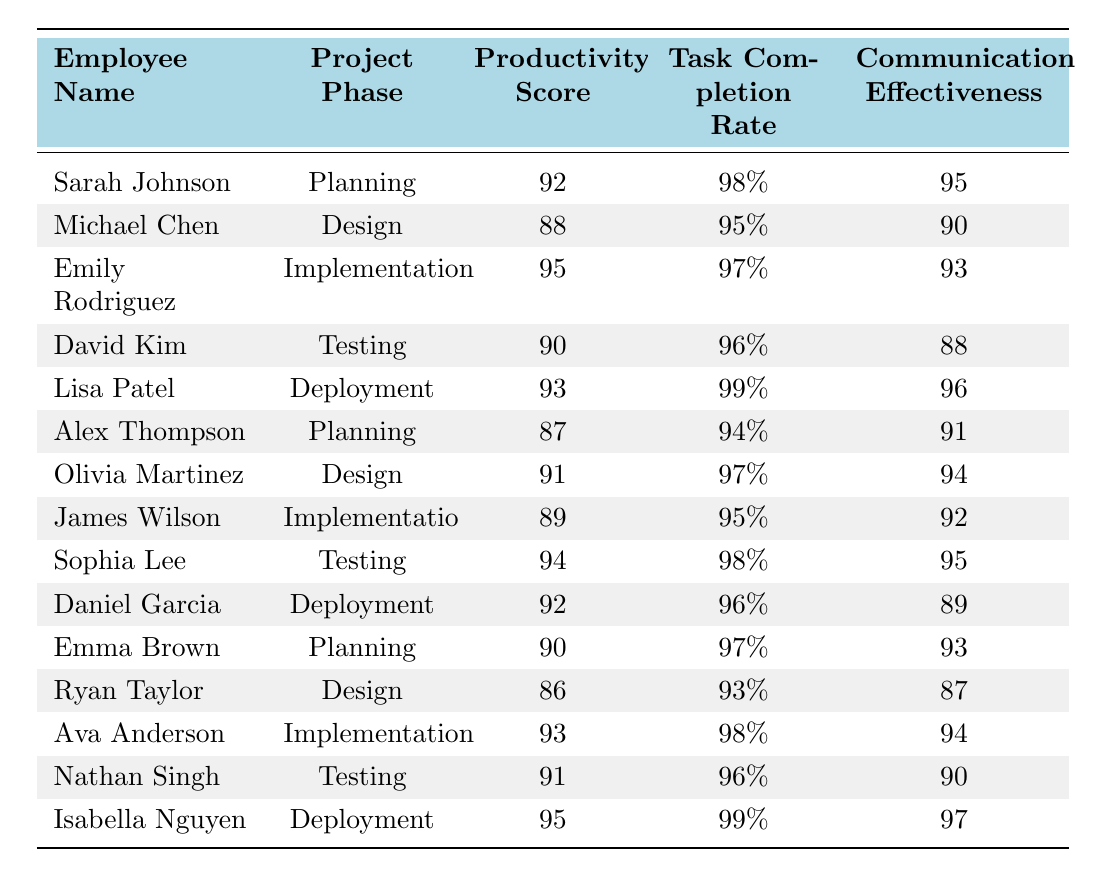What is the productivity score of Sarah Johnson in the Planning phase? Sarah Johnson's productivity score in the Planning phase is directly mentioned in the table, which shows 92.
Answer: 92 Which project phase has the highest productivity score? The productivity scores for each phase are: Planning (maximum 92), Design (maximum 91), Implementation (maximum 95), Testing (maximum 94), and Deployment (maximum 95). The maximum score of 95 occurs in the Implementation phase and is also seen in the Deployment phase, but Implementation has the highest recorded score.
Answer: Implementation What is the average task completion rate for the Design phase? The task completion rates for the Design phase are 95%, 97%, and 93% for Michael Chen, Olivia Martinez, and Ryan Taylor. Summing these gives 95 + 97 + 93 = 285. Dividing by 3 (the number of employees) gives 285/3 = 95%.
Answer: 95% Is Emily Rodriguez the only employee in the Implementation phase? The table shows three employees in the Implementation phase: Emily Rodriguez, James Wilson, and Ava Anderson, indicating that she is not the only one.
Answer: No What is the difference between the highest and lowest productivity scores in the Planning phase? The highest productivity score in the Planning phase is 92 (Sarah Johnson) and the lowest is 87 (Alex Thompson). The difference is calculated as 92 - 87 = 5.
Answer: 5 Which employee had the highest communication effectiveness score in the Deployment phase? The communication effectiveness scores in the Deployment phase are: Lisa Patel (96), Daniel Garcia (89), and Isabella Nguyen (97). Among these, Isabella Nguyen has the highest score of 97.
Answer: Isabella Nguyen Summarize the average productivity score across all project phases. The productivity scores are: 92, 88, 95, 90, 93, 87, 91, 89, 94, 92, 90, 86, 93, 91, and 95. The total sum is 1332, and there are 15 employees. Dividing gives an average score of 1332/15 = 88.8.
Answer: 88.8 Which phase had the lowest task completion rate overall? Reviewing the task completion rates: Planning (98%, 94%, 97%), Design (95%, 97%, 93%), Implementation (97%, 95%, 98%), Testing (96%, 98%, 96%), and Deployment (99%, 96%, 99%). The lowest rate is 93% in the Design phase.
Answer: Design Are all employees in the Deployment phase scoring above 90 in communication effectiveness? In the Deployment phase, the communication effectiveness scores are 96 (Lisa Patel), 89 (Daniel Garcia), and 97 (Isabella Nguyen). Since 89 is below 90, not all employees pass this criterion.
Answer: No What is the maximum productivity score for any employee in the Testing phase? The productivity scores for Testing are: 90 (David Kim), 94 (Sophia Lee), and 91 (Nathan Singh). The maximum score among these is 94 from Sophia Lee.
Answer: 94 